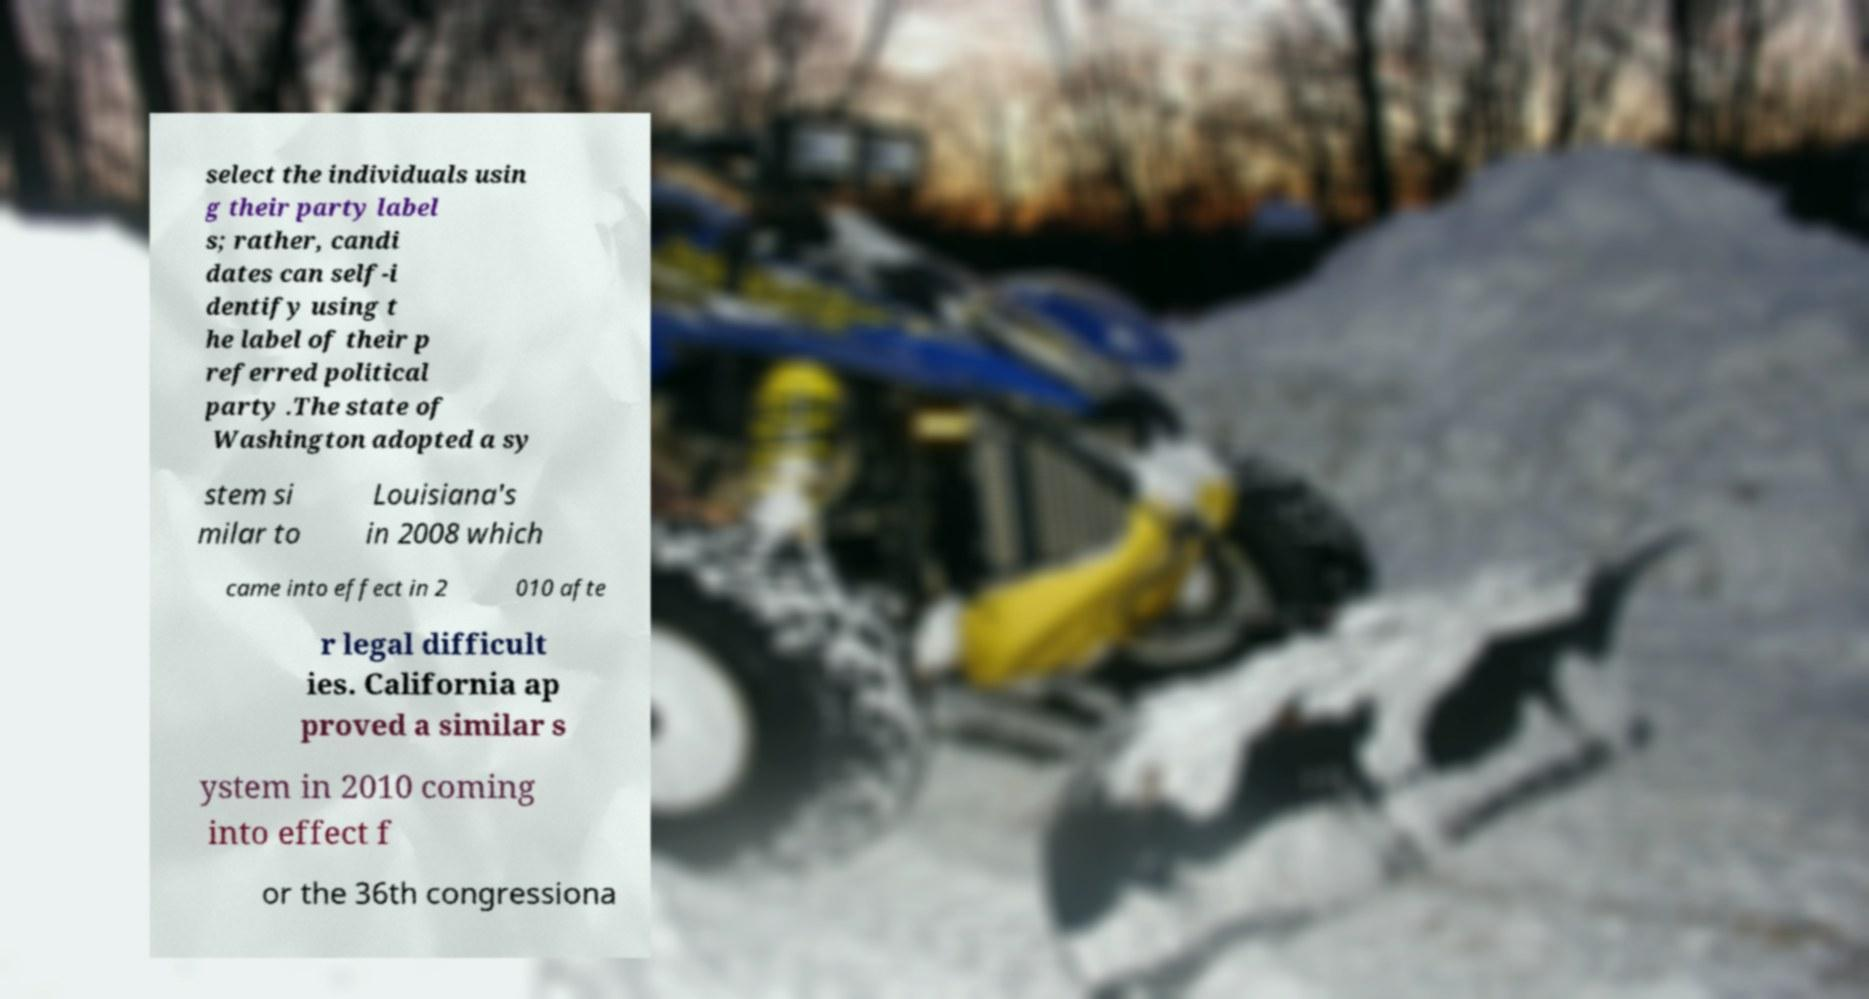I need the written content from this picture converted into text. Can you do that? select the individuals usin g their party label s; rather, candi dates can self-i dentify using t he label of their p referred political party .The state of Washington adopted a sy stem si milar to Louisiana's in 2008 which came into effect in 2 010 afte r legal difficult ies. California ap proved a similar s ystem in 2010 coming into effect f or the 36th congressiona 